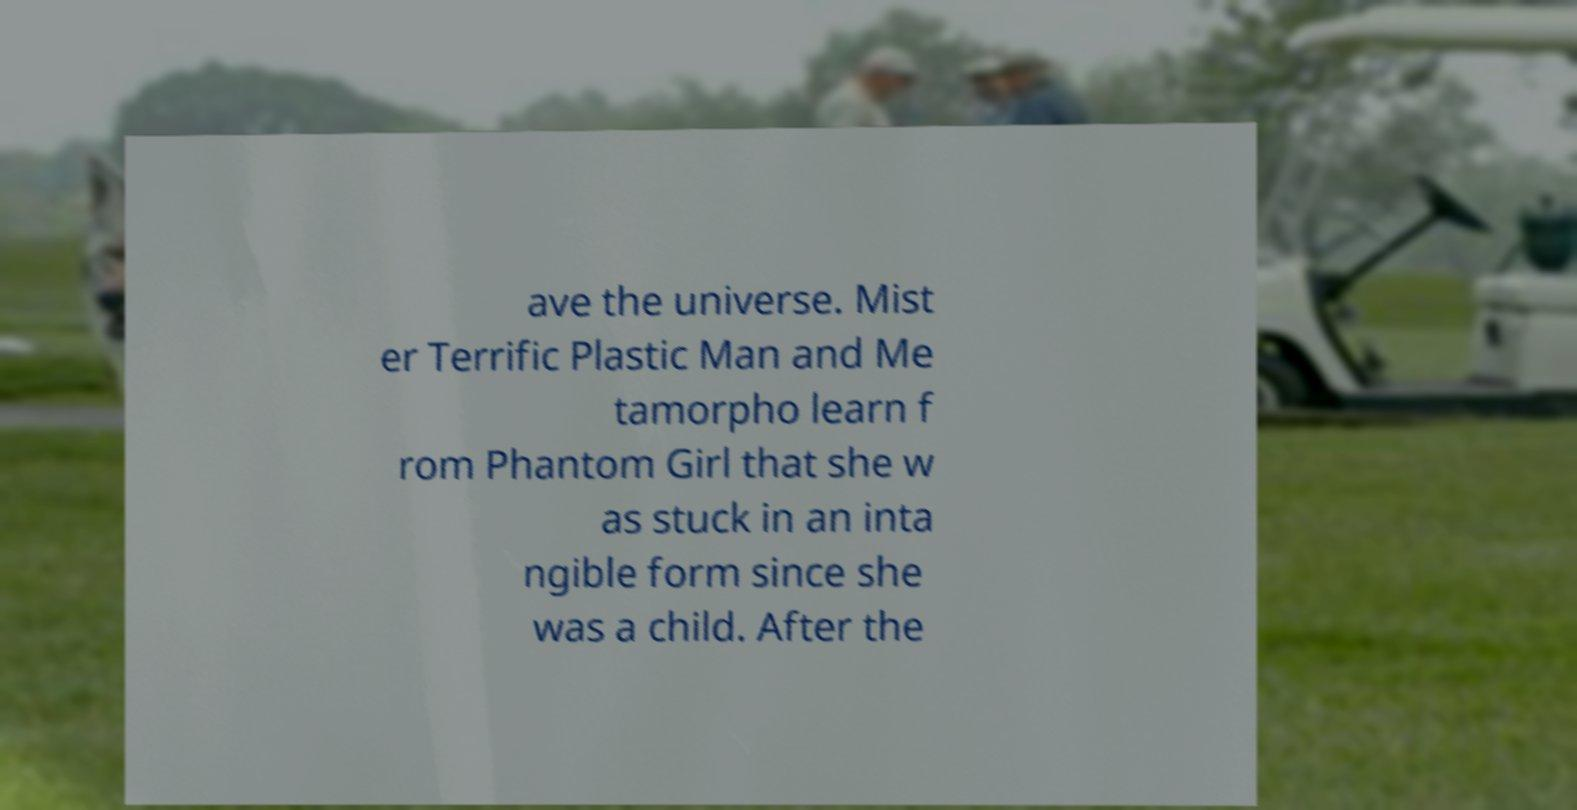I need the written content from this picture converted into text. Can you do that? ave the universe. Mist er Terrific Plastic Man and Me tamorpho learn f rom Phantom Girl that she w as stuck in an inta ngible form since she was a child. After the 